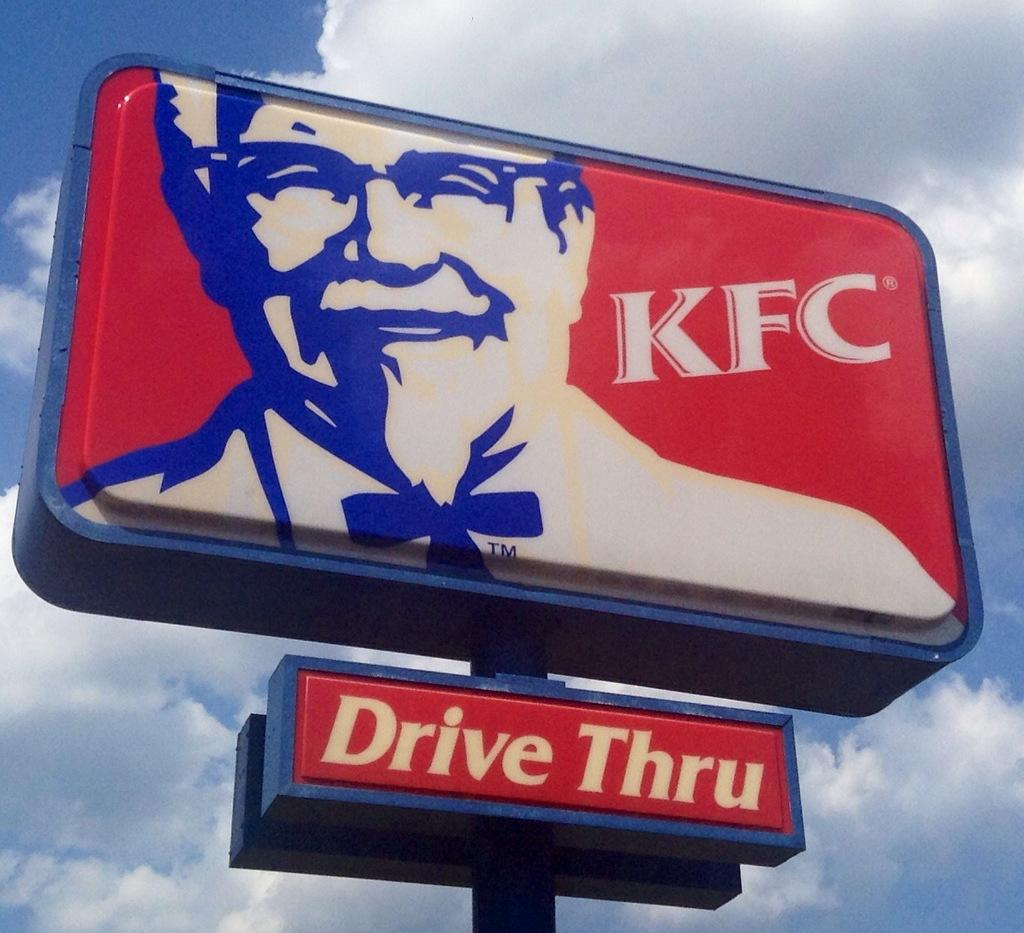<image>
Summarize the visual content of the image. A KFC sign says it has a drive thru. 